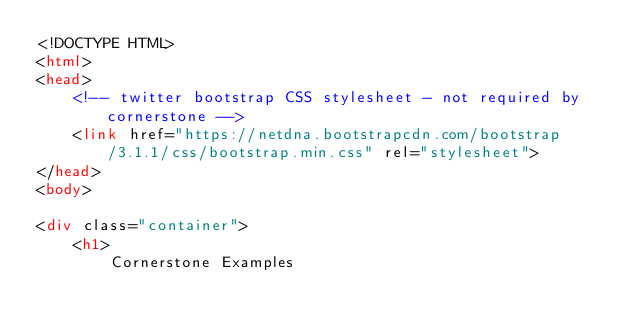Convert code to text. <code><loc_0><loc_0><loc_500><loc_500><_HTML_><!DOCTYPE HTML>
<html>
<head>
    <!-- twitter bootstrap CSS stylesheet - not required by cornerstone -->
    <link href="https://netdna.bootstrapcdn.com/bootstrap/3.1.1/css/bootstrap.min.css" rel="stylesheet">
</head>
<body>

<div class="container">
    <h1>
        Cornerstone Examples</code> 